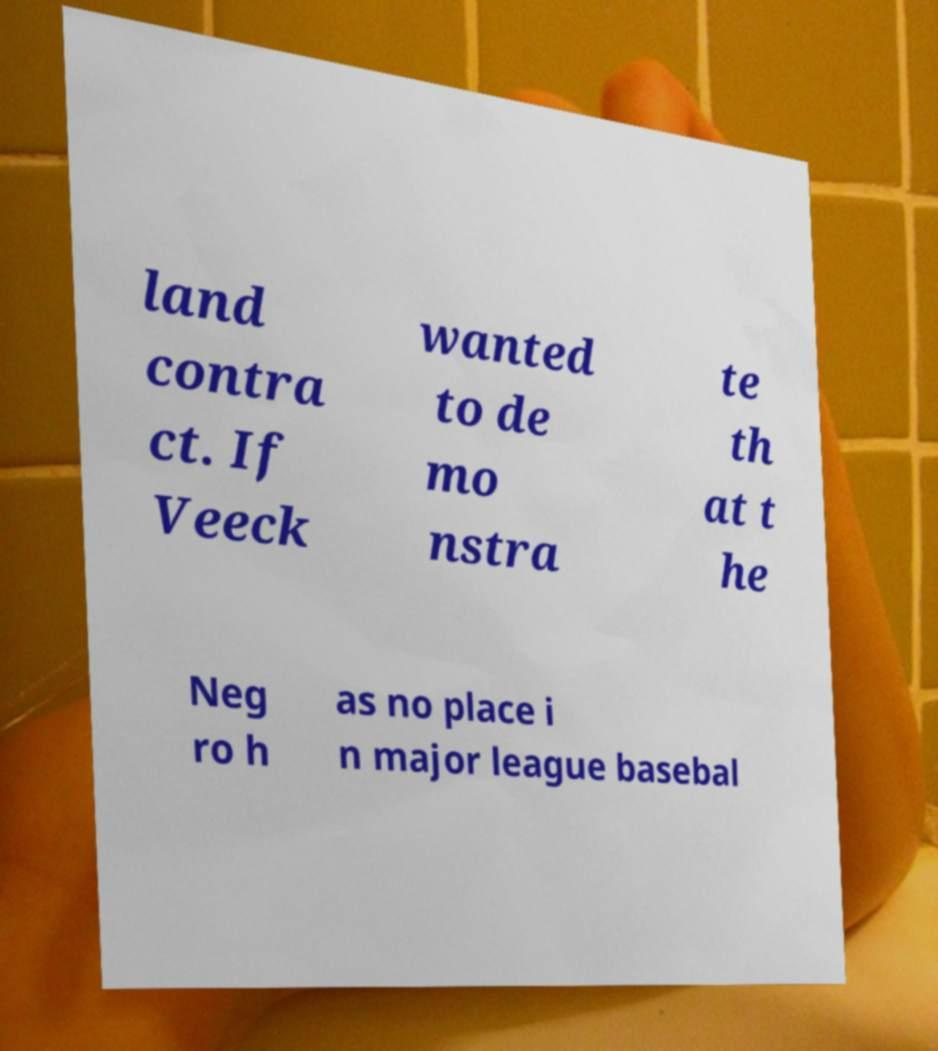Please identify and transcribe the text found in this image. land contra ct. If Veeck wanted to de mo nstra te th at t he Neg ro h as no place i n major league basebal 